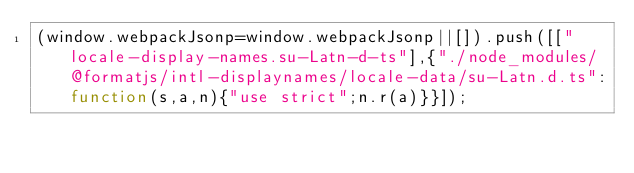Convert code to text. <code><loc_0><loc_0><loc_500><loc_500><_JavaScript_>(window.webpackJsonp=window.webpackJsonp||[]).push([["locale-display-names.su-Latn-d-ts"],{"./node_modules/@formatjs/intl-displaynames/locale-data/su-Latn.d.ts":function(s,a,n){"use strict";n.r(a)}}]);</code> 